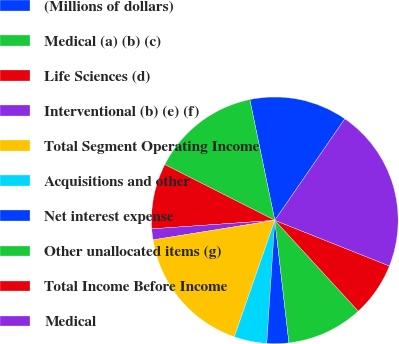<chart> <loc_0><loc_0><loc_500><loc_500><pie_chart><fcel>(Millions of dollars)<fcel>Medical (a) (b) (c)<fcel>Life Sciences (d)<fcel>Interventional (b) (e) (f)<fcel>Total Segment Operating Income<fcel>Acquisitions and other<fcel>Net interest expense<fcel>Other unallocated items (g)<fcel>Total Income Before Income<fcel>Medical<nl><fcel>12.86%<fcel>14.28%<fcel>8.57%<fcel>1.43%<fcel>17.14%<fcel>4.29%<fcel>2.86%<fcel>10.0%<fcel>7.14%<fcel>21.42%<nl></chart> 